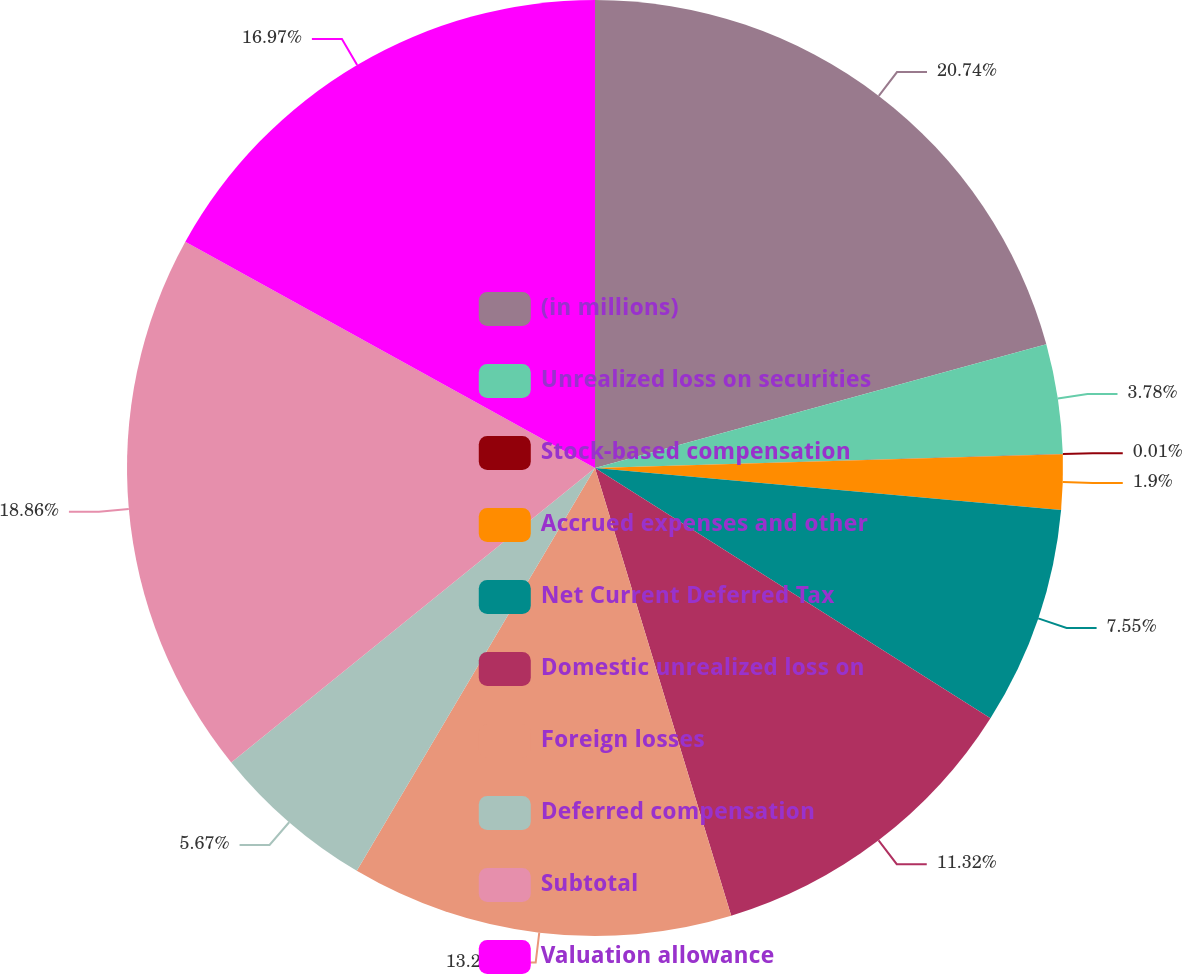<chart> <loc_0><loc_0><loc_500><loc_500><pie_chart><fcel>(in millions)<fcel>Unrealized loss on securities<fcel>Stock-based compensation<fcel>Accrued expenses and other<fcel>Net Current Deferred Tax<fcel>Domestic unrealized loss on<fcel>Foreign losses<fcel>Deferred compensation<fcel>Subtotal<fcel>Valuation allowance<nl><fcel>20.74%<fcel>3.78%<fcel>0.01%<fcel>1.9%<fcel>7.55%<fcel>11.32%<fcel>13.2%<fcel>5.67%<fcel>18.86%<fcel>16.97%<nl></chart> 